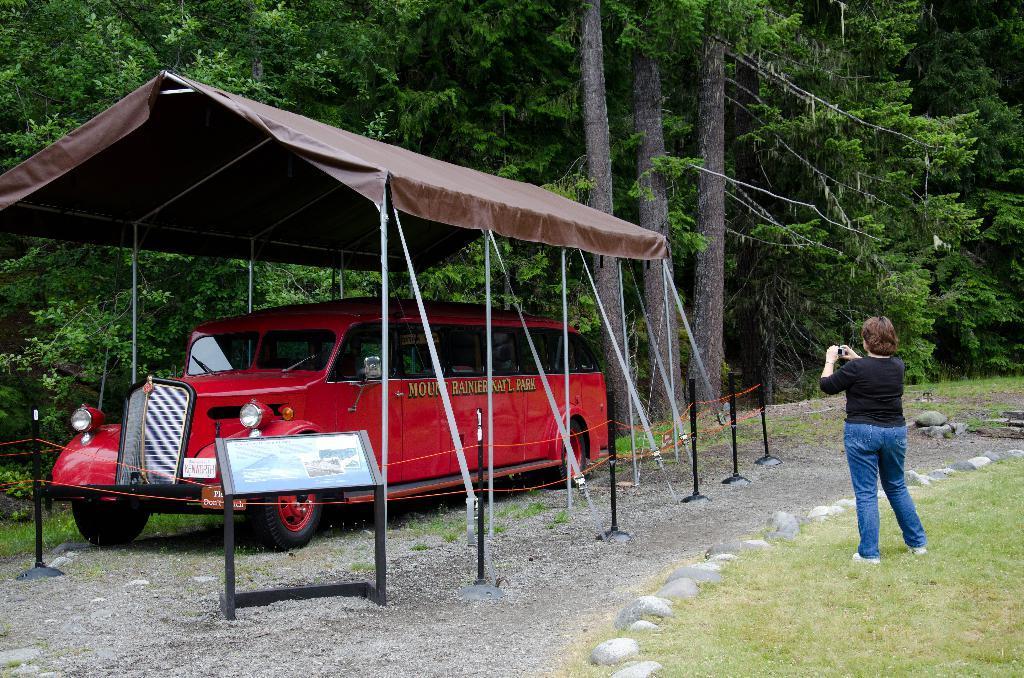Describe this image in one or two sentences. In this image there is a land on that land there is a car under tent, there is a woman standing on the land, in the background there are trees. 